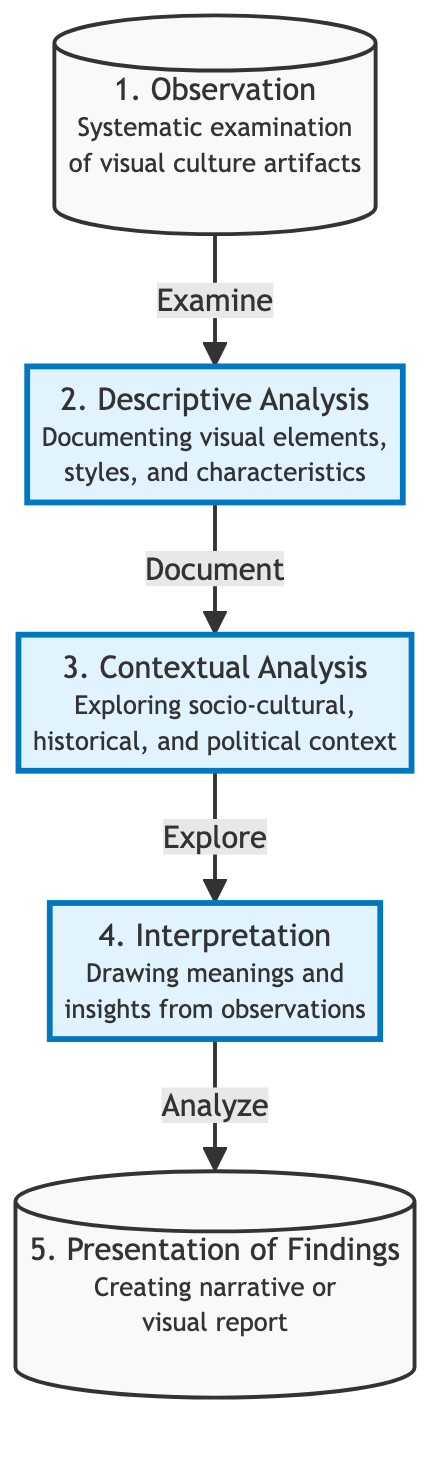What is the first step in the flow chart? The first step in the flow chart is labeled "Observation," focusing on the systematic examination of visual culture artifacts.
Answer: Observation How many steps are there in the flow chart? The flow chart consists of five steps: Observation, Descriptive Analysis, Contextual Analysis, Interpretation, and Presentation of Findings.
Answer: 5 What is the last step in the process? The last step in the process, according to the flow chart, is "Presentation of Findings," where insights are shared.
Answer: Presentation of Findings What action follows the “Descriptive Analysis"? Following "Descriptive Analysis," the action that occurs is "Contextual Analysis," where the socio-cultural and historical context is explored.
Answer: Contextual Analysis Which step involves drawing meanings and insights? The step involving drawing meanings and insights is labeled "Interpretation," based on observations and context.
Answer: Interpretation What is described in the second step? The second step, "Descriptive Analysis," describes documenting the visual elements, styles, and characteristics of the artifacts.
Answer: Documenting visual elements, styles, and characteristics Which two steps are connected by the action "Explore"? The two steps connected by the action "Explore" are "Contextual Analysis" and "Interpretation."
Answer: Contextual Analysis and Interpretation What do the highlighted nodes represent in the flow chart? The highlighted nodes represent the steps of "Descriptive Analysis," "Contextual Analysis," and "Interpretation," indicating they are key stages in the analysis process.
Answer: Key stages in the analysis process What is the relationship between "Observation" and "Descriptive Analysis"? The relationship is directional, with "Observation" leading to "Descriptive Analysis" through the action of examining visual culture artifacts.
Answer: Examination What follows after "Interpretation"? After "Interpretation," the next step in the flow is "Presentation of Findings," where findings and insights are shared.
Answer: Presentation of Findings 